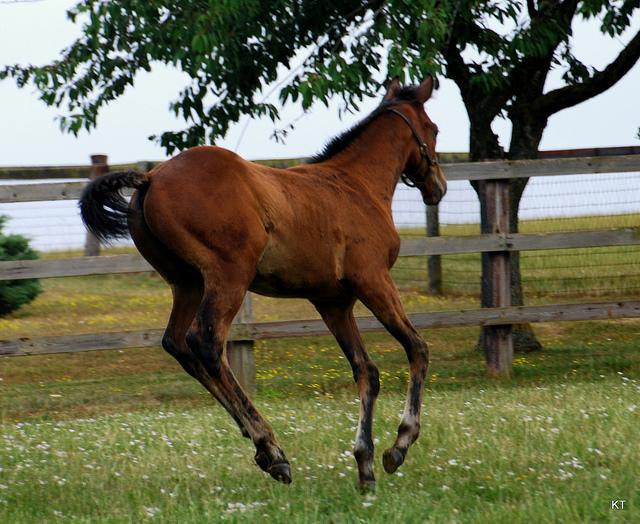Do the fence planks go horizontally or vertically?
Write a very short answer. Horizontally. What letters are in the picture?
Answer briefly. Kt. Is the horse galloping?
Concise answer only. Yes. Does this horse look healthy?
Answer briefly. Yes. Is this animal an adult?
Quick response, please. No. Is this a young or old horse?
Concise answer only. Young. 